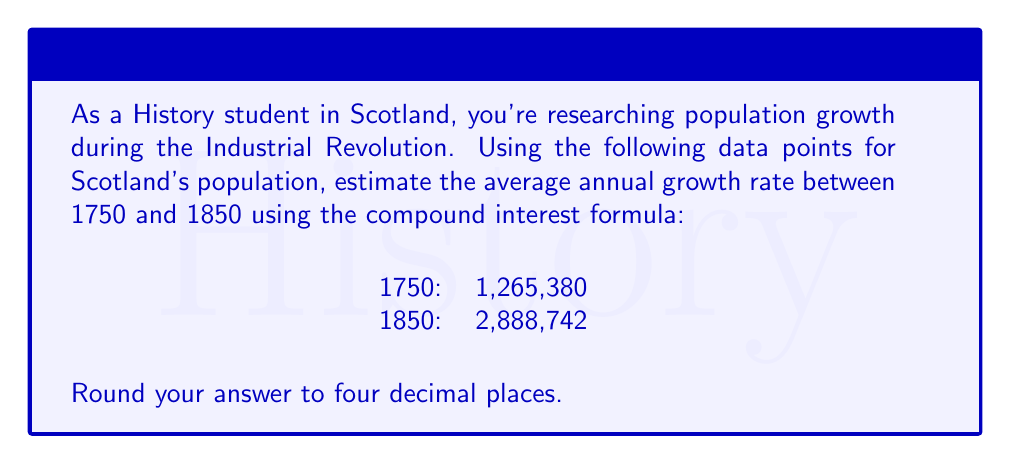Help me with this question. To solve this problem, we'll use the compound interest formula:

$$ P(t) = P_0(1 + r)^t $$

Where:
$P(t)$ is the final population
$P_0$ is the initial population
$r$ is the annual growth rate
$t$ is the time in years

We know:
$P_0 = 1,265,380$ (population in 1750)
$P(t) = 2,888,742$ (population in 1850)
$t = 100$ years

Substituting these values into the formula:

$$ 2,888,742 = 1,265,380(1 + r)^{100} $$

To solve for $r$, we need to isolate it:

1. Divide both sides by 1,265,380:
   $$ \frac{2,888,742}{1,265,380} = (1 + r)^{100} $$

2. Take the 100th root of both sides:
   $$ \sqrt[100]{\frac{2,888,742}{1,265,380}} = 1 + r $$

3. Subtract 1 from both sides:
   $$ \sqrt[100]{\frac{2,888,742}{1,265,380}} - 1 = r $$

4. Calculate the result:
   $$ r = \sqrt[100]{2.282913} - 1 $$
   $$ r = 1.00822916 - 1 $$
   $$ r = 0.00822916 $$

5. Round to four decimal places:
   $$ r \approx 0.0082 $$

Therefore, the estimated average annual growth rate is 0.0082 or 0.82%.
Answer: 0.0082 